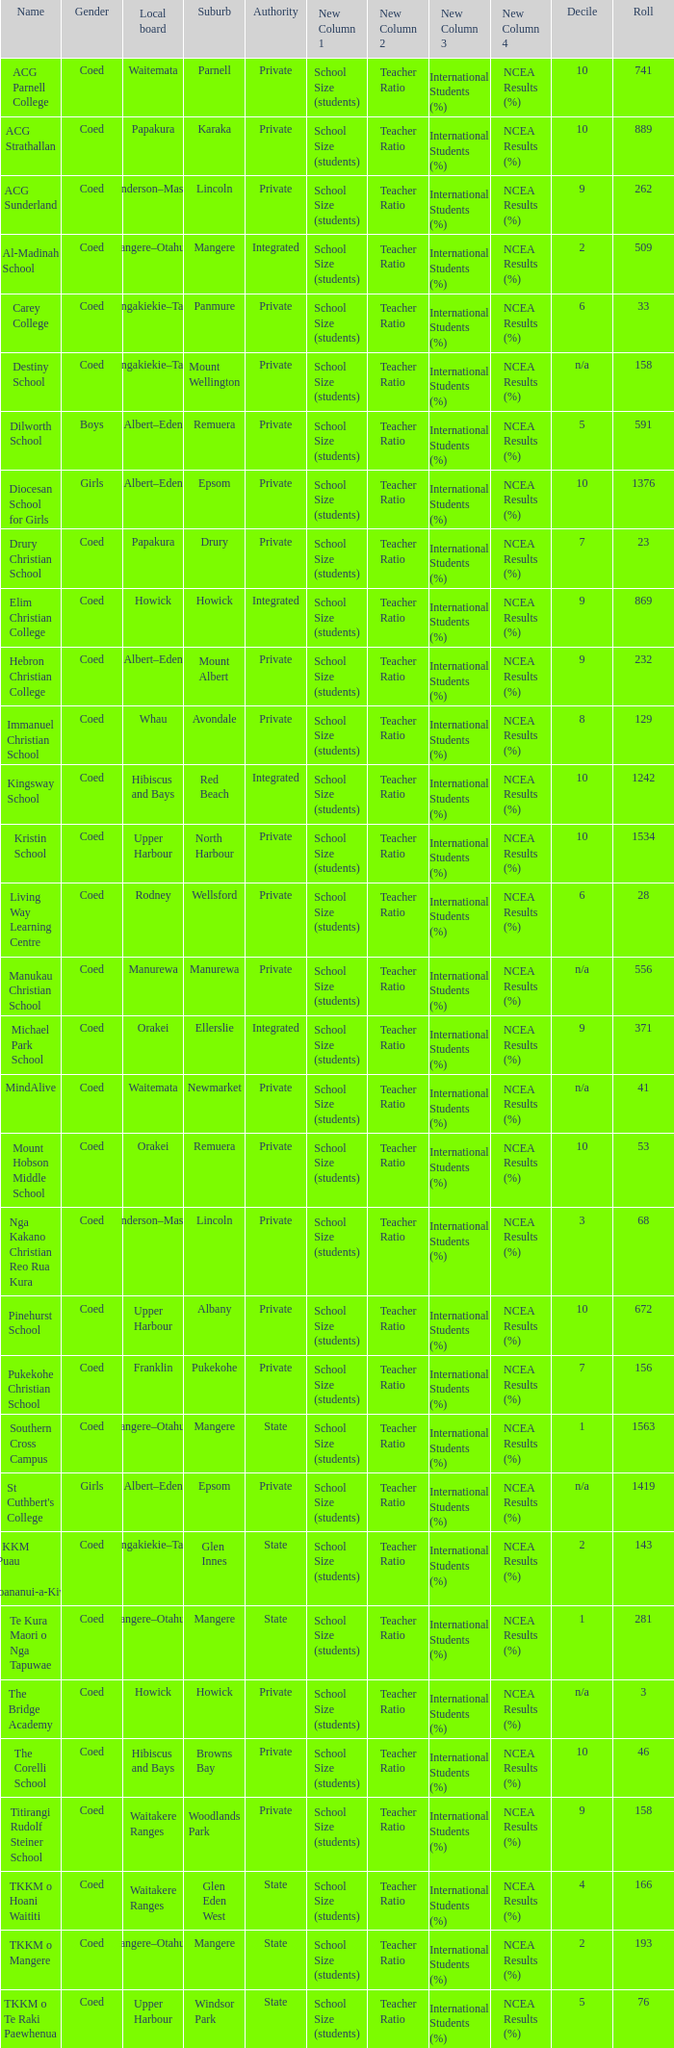What name shows as private authority and hibiscus and bays local board ? The Corelli School. 